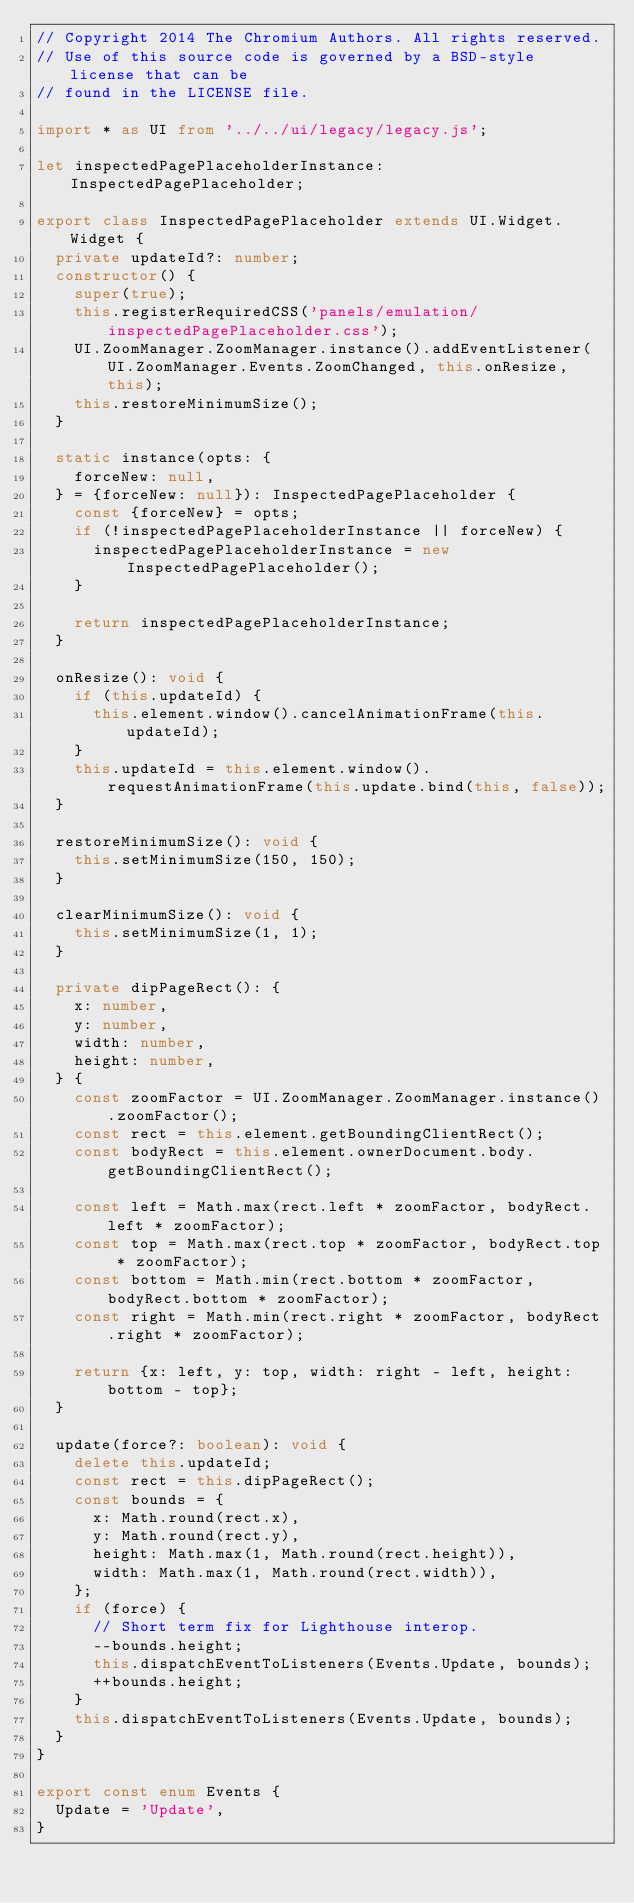<code> <loc_0><loc_0><loc_500><loc_500><_TypeScript_>// Copyright 2014 The Chromium Authors. All rights reserved.
// Use of this source code is governed by a BSD-style license that can be
// found in the LICENSE file.

import * as UI from '../../ui/legacy/legacy.js';

let inspectedPagePlaceholderInstance: InspectedPagePlaceholder;

export class InspectedPagePlaceholder extends UI.Widget.Widget {
  private updateId?: number;
  constructor() {
    super(true);
    this.registerRequiredCSS('panels/emulation/inspectedPagePlaceholder.css');
    UI.ZoomManager.ZoomManager.instance().addEventListener(UI.ZoomManager.Events.ZoomChanged, this.onResize, this);
    this.restoreMinimumSize();
  }

  static instance(opts: {
    forceNew: null,
  } = {forceNew: null}): InspectedPagePlaceholder {
    const {forceNew} = opts;
    if (!inspectedPagePlaceholderInstance || forceNew) {
      inspectedPagePlaceholderInstance = new InspectedPagePlaceholder();
    }

    return inspectedPagePlaceholderInstance;
  }

  onResize(): void {
    if (this.updateId) {
      this.element.window().cancelAnimationFrame(this.updateId);
    }
    this.updateId = this.element.window().requestAnimationFrame(this.update.bind(this, false));
  }

  restoreMinimumSize(): void {
    this.setMinimumSize(150, 150);
  }

  clearMinimumSize(): void {
    this.setMinimumSize(1, 1);
  }

  private dipPageRect(): {
    x: number,
    y: number,
    width: number,
    height: number,
  } {
    const zoomFactor = UI.ZoomManager.ZoomManager.instance().zoomFactor();
    const rect = this.element.getBoundingClientRect();
    const bodyRect = this.element.ownerDocument.body.getBoundingClientRect();

    const left = Math.max(rect.left * zoomFactor, bodyRect.left * zoomFactor);
    const top = Math.max(rect.top * zoomFactor, bodyRect.top * zoomFactor);
    const bottom = Math.min(rect.bottom * zoomFactor, bodyRect.bottom * zoomFactor);
    const right = Math.min(rect.right * zoomFactor, bodyRect.right * zoomFactor);

    return {x: left, y: top, width: right - left, height: bottom - top};
  }

  update(force?: boolean): void {
    delete this.updateId;
    const rect = this.dipPageRect();
    const bounds = {
      x: Math.round(rect.x),
      y: Math.round(rect.y),
      height: Math.max(1, Math.round(rect.height)),
      width: Math.max(1, Math.round(rect.width)),
    };
    if (force) {
      // Short term fix for Lighthouse interop.
      --bounds.height;
      this.dispatchEventToListeners(Events.Update, bounds);
      ++bounds.height;
    }
    this.dispatchEventToListeners(Events.Update, bounds);
  }
}

export const enum Events {
  Update = 'Update',
}
</code> 